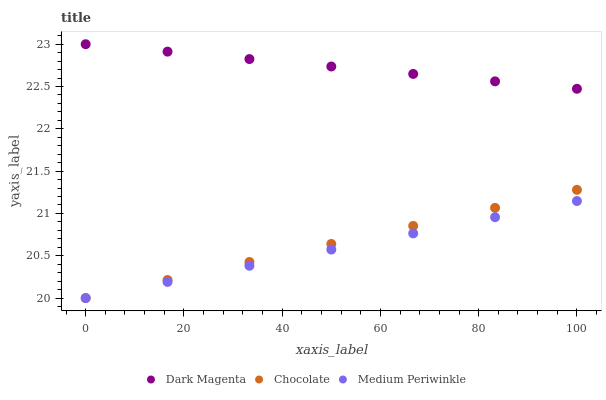Does Medium Periwinkle have the minimum area under the curve?
Answer yes or no. Yes. Does Dark Magenta have the maximum area under the curve?
Answer yes or no. Yes. Does Chocolate have the minimum area under the curve?
Answer yes or no. No. Does Chocolate have the maximum area under the curve?
Answer yes or no. No. Is Dark Magenta the smoothest?
Answer yes or no. Yes. Is Medium Periwinkle the roughest?
Answer yes or no. Yes. Is Chocolate the smoothest?
Answer yes or no. No. Is Chocolate the roughest?
Answer yes or no. No. Does Medium Periwinkle have the lowest value?
Answer yes or no. Yes. Does Dark Magenta have the lowest value?
Answer yes or no. No. Does Dark Magenta have the highest value?
Answer yes or no. Yes. Does Chocolate have the highest value?
Answer yes or no. No. Is Chocolate less than Dark Magenta?
Answer yes or no. Yes. Is Dark Magenta greater than Chocolate?
Answer yes or no. Yes. Does Chocolate intersect Medium Periwinkle?
Answer yes or no. Yes. Is Chocolate less than Medium Periwinkle?
Answer yes or no. No. Is Chocolate greater than Medium Periwinkle?
Answer yes or no. No. Does Chocolate intersect Dark Magenta?
Answer yes or no. No. 